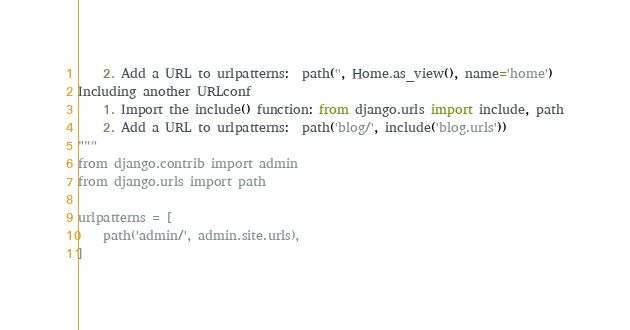Convert code to text. <code><loc_0><loc_0><loc_500><loc_500><_Python_>    2. Add a URL to urlpatterns:  path('', Home.as_view(), name='home')
Including another URLconf
    1. Import the include() function: from django.urls import include, path
    2. Add a URL to urlpatterns:  path('blog/', include('blog.urls'))
"""
from django.contrib import admin
from django.urls import path

urlpatterns = [
    path('admin/', admin.site.urls),
]
</code> 